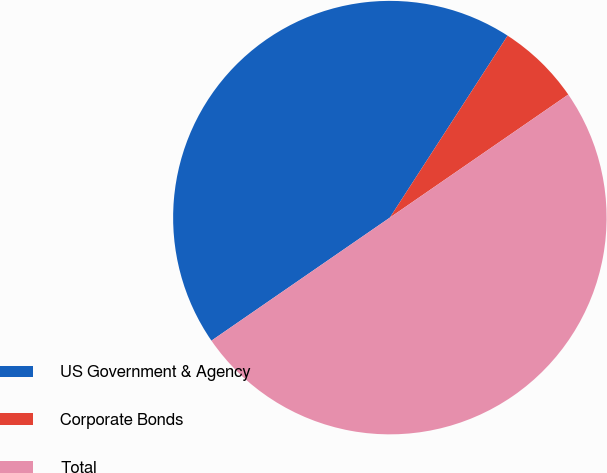Convert chart. <chart><loc_0><loc_0><loc_500><loc_500><pie_chart><fcel>US Government & Agency<fcel>Corporate Bonds<fcel>Total<nl><fcel>43.75%<fcel>6.25%<fcel>50.0%<nl></chart> 